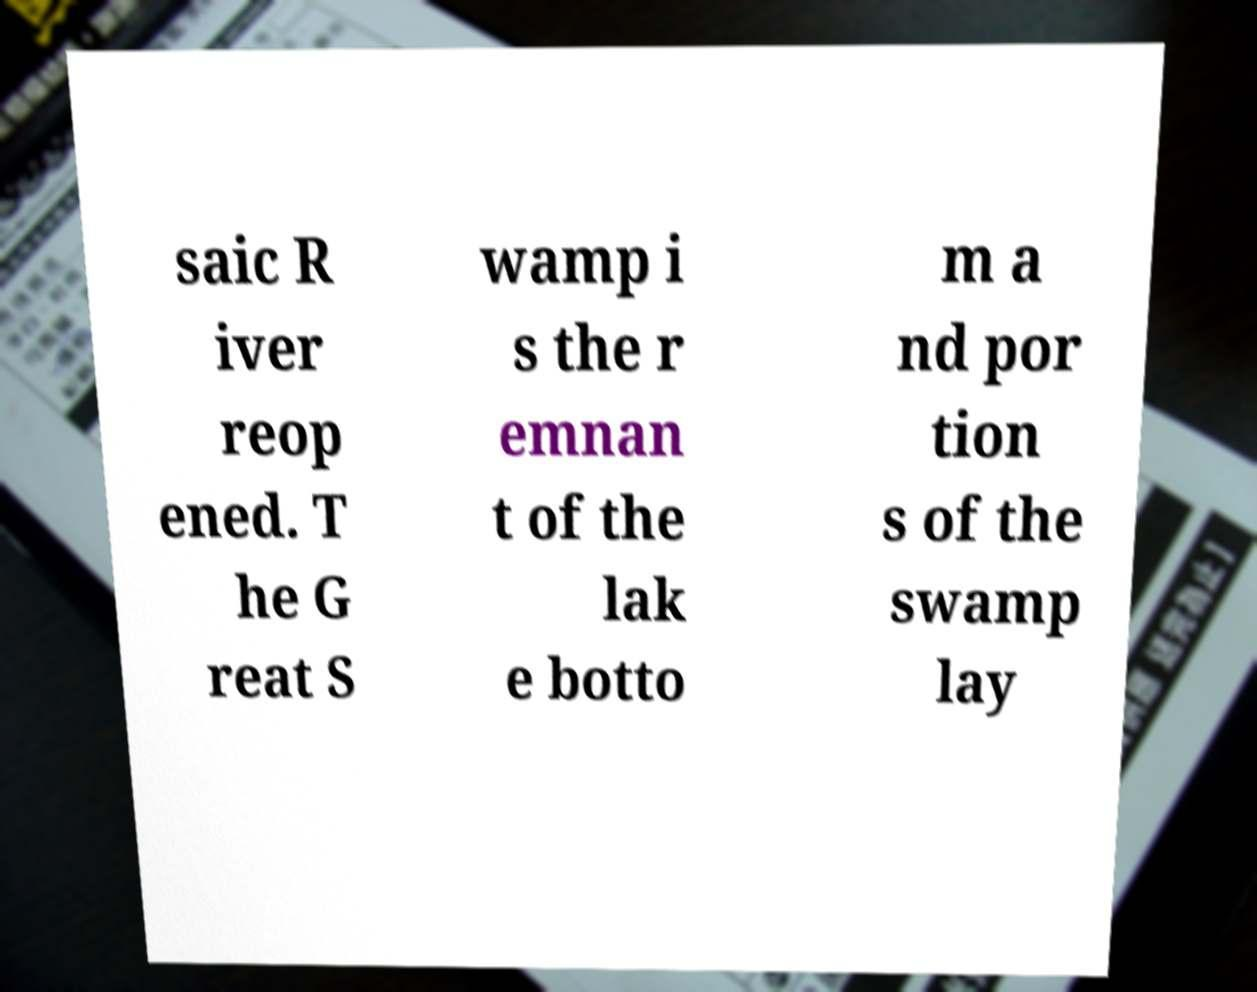Please identify and transcribe the text found in this image. saic R iver reop ened. T he G reat S wamp i s the r emnan t of the lak e botto m a nd por tion s of the swamp lay 